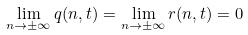<formula> <loc_0><loc_0><loc_500><loc_500>\lim _ { n \to \pm \infty } q ( n , t ) = \lim _ { n \to \pm \infty } r ( n , t ) = 0</formula> 